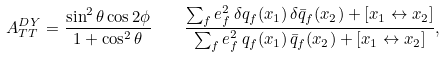Convert formula to latex. <formula><loc_0><loc_0><loc_500><loc_500>A _ { T T } ^ { D Y } = { \frac { \sin ^ { 2 } \theta \cos { 2 \phi } } { 1 + \cos ^ { 2 } \theta } } \quad \frac { \sum _ { f } e _ { f } ^ { 2 } \, \delta q _ { f } ( x _ { 1 } ) \, \delta \bar { q } _ { f } ( x _ { 2 } ) + [ x _ { 1 } \leftrightarrow x _ { 2 } ] } { \sum _ { f } e _ { f } ^ { 2 } \, q _ { f } ( x _ { 1 } ) \, \bar { q } _ { f } ( x _ { 2 } ) + [ x _ { 1 } \leftrightarrow x _ { 2 } ] } ,</formula> 